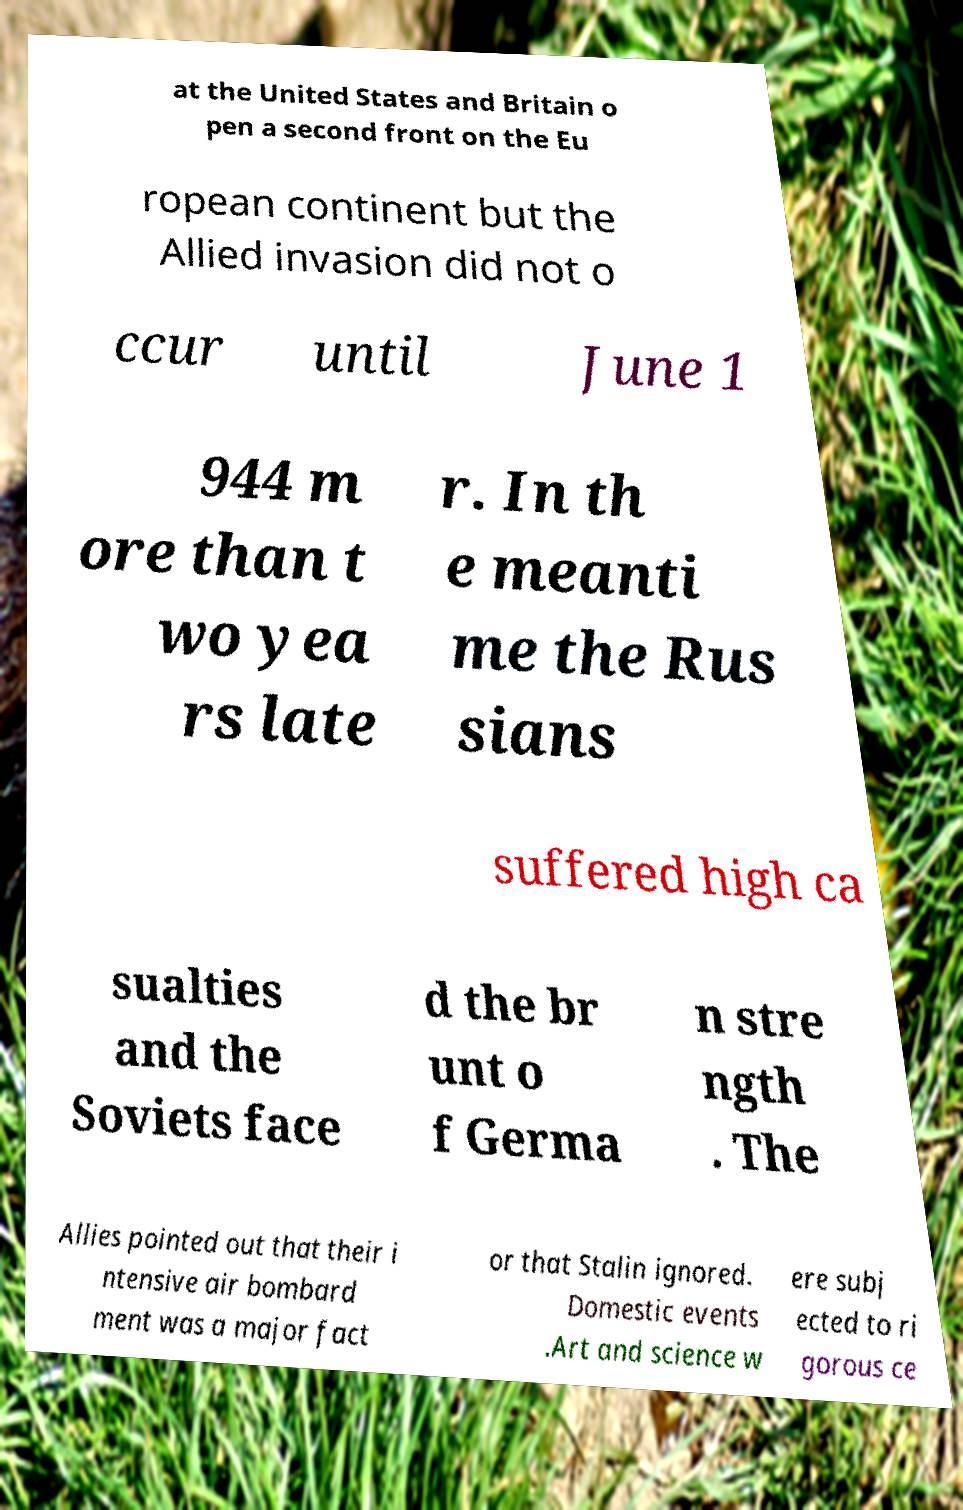Could you extract and type out the text from this image? at the United States and Britain o pen a second front on the Eu ropean continent but the Allied invasion did not o ccur until June 1 944 m ore than t wo yea rs late r. In th e meanti me the Rus sians suffered high ca sualties and the Soviets face d the br unt o f Germa n stre ngth . The Allies pointed out that their i ntensive air bombard ment was a major fact or that Stalin ignored. Domestic events .Art and science w ere subj ected to ri gorous ce 